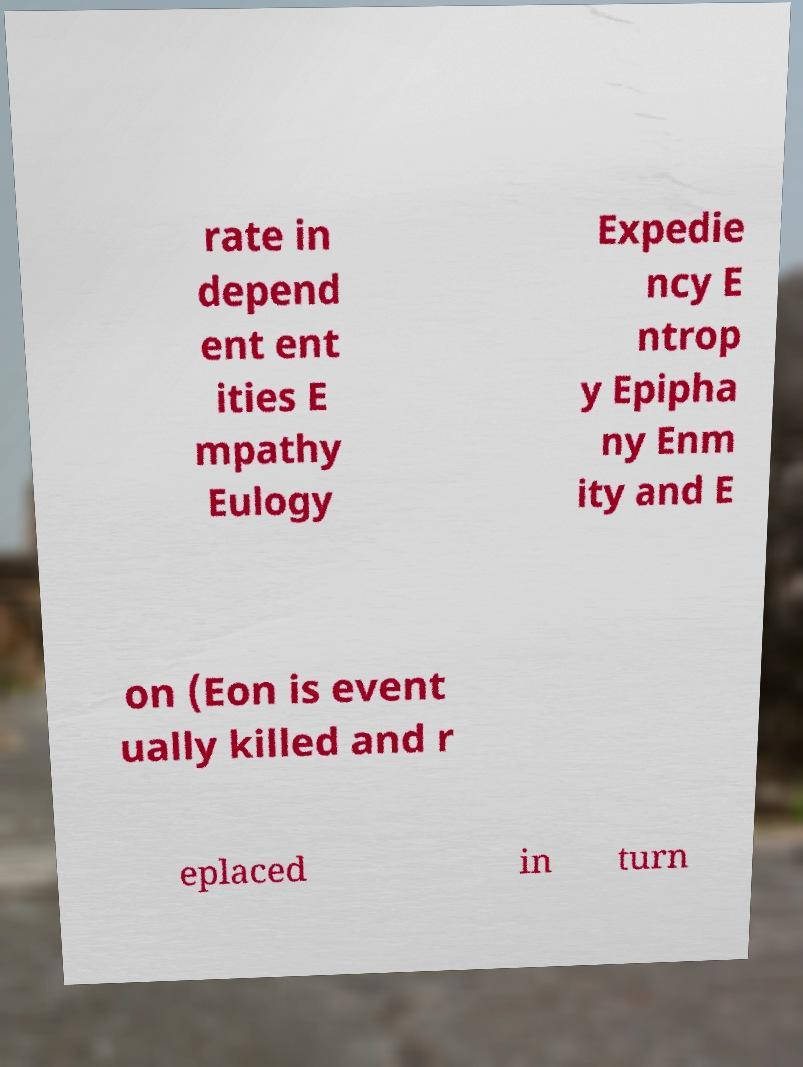Can you accurately transcribe the text from the provided image for me? rate in depend ent ent ities E mpathy Eulogy Expedie ncy E ntrop y Epipha ny Enm ity and E on (Eon is event ually killed and r eplaced in turn 